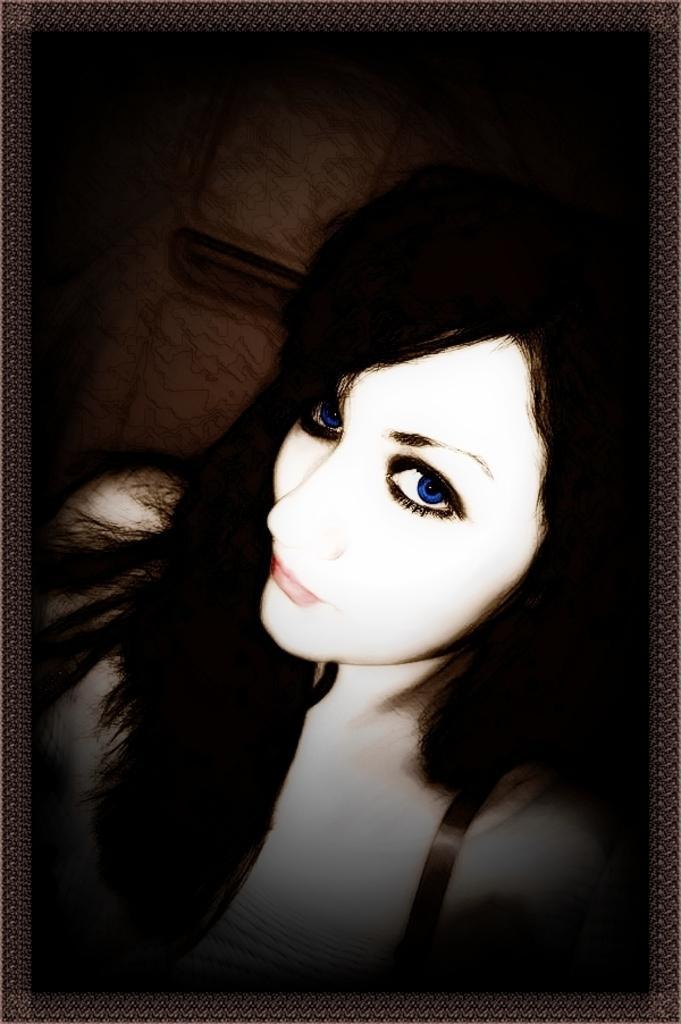Please provide a concise description of this image. In this image we can see one woman and at the background one object attached to the wall. 